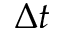Convert formula to latex. <formula><loc_0><loc_0><loc_500><loc_500>\Delta t</formula> 